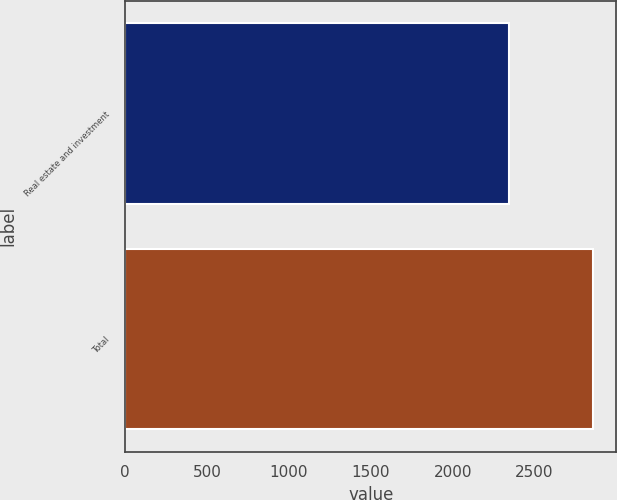Convert chart to OTSL. <chart><loc_0><loc_0><loc_500><loc_500><bar_chart><fcel>Real estate and investment<fcel>Total<nl><fcel>2343<fcel>2857<nl></chart> 